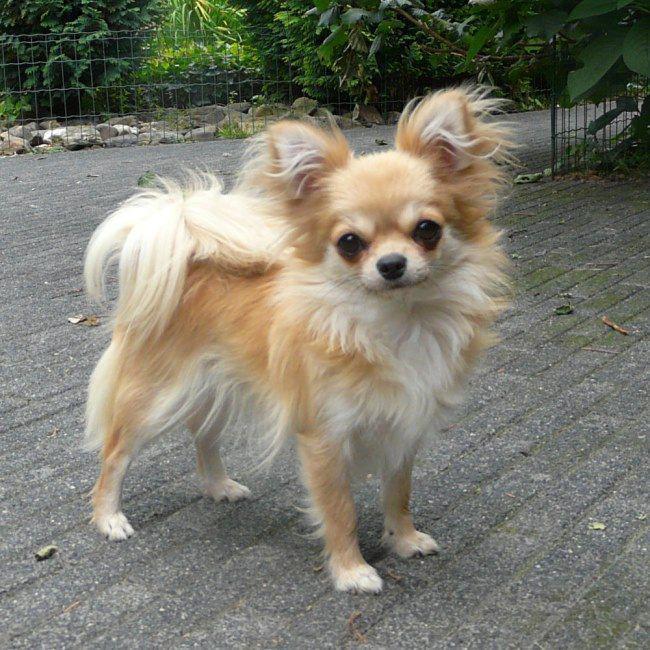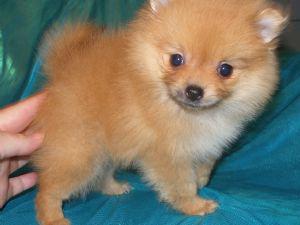The first image is the image on the left, the second image is the image on the right. Analyze the images presented: Is the assertion "Each image contains one dog on a leash." valid? Answer yes or no. No. 